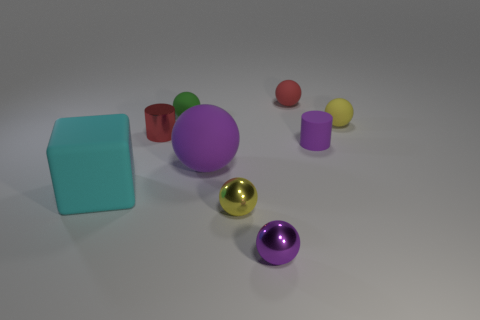What is the shape of the matte thing that is on the left side of the large purple matte ball and behind the purple rubber cylinder? The object you're referring to is a cube. It is matte and cyan in color, located on the left side of the large purple matte sphere and directly behind the smaller purple glossy cylinder. 